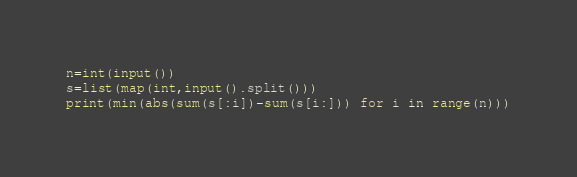<code> <loc_0><loc_0><loc_500><loc_500><_Python_>n=int(input())
s=list(map(int,input().split()))
print(min(abs(sum(s[:i])-sum(s[i:])) for i in range(n)))</code> 